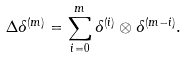Convert formula to latex. <formula><loc_0><loc_0><loc_500><loc_500>\Delta \delta ^ { ( m ) } = \sum _ { i = 0 } ^ { m } \delta ^ { ( i ) } \otimes \delta ^ { ( m - i ) } .</formula> 